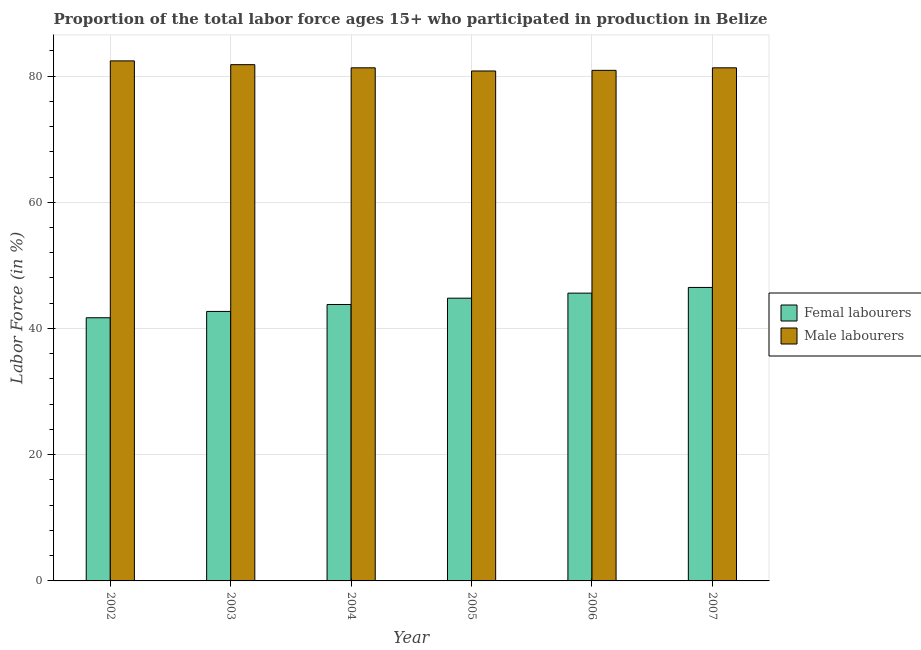How many different coloured bars are there?
Offer a very short reply. 2. How many groups of bars are there?
Provide a succinct answer. 6. Are the number of bars on each tick of the X-axis equal?
Ensure brevity in your answer.  Yes. What is the label of the 5th group of bars from the left?
Your answer should be very brief. 2006. In how many cases, is the number of bars for a given year not equal to the number of legend labels?
Offer a very short reply. 0. What is the percentage of male labour force in 2007?
Offer a very short reply. 81.3. Across all years, what is the maximum percentage of female labor force?
Your response must be concise. 46.5. Across all years, what is the minimum percentage of female labor force?
Your answer should be very brief. 41.7. In which year was the percentage of male labour force maximum?
Your answer should be very brief. 2002. In which year was the percentage of male labour force minimum?
Your answer should be compact. 2005. What is the total percentage of male labour force in the graph?
Provide a short and direct response. 488.5. What is the average percentage of male labour force per year?
Make the answer very short. 81.42. In the year 2004, what is the difference between the percentage of female labor force and percentage of male labour force?
Provide a short and direct response. 0. In how many years, is the percentage of female labor force greater than 16 %?
Your answer should be compact. 6. What is the ratio of the percentage of female labor force in 2003 to that in 2004?
Give a very brief answer. 0.97. Is the difference between the percentage of female labor force in 2002 and 2007 greater than the difference between the percentage of male labour force in 2002 and 2007?
Make the answer very short. No. What is the difference between the highest and the second highest percentage of male labour force?
Your answer should be very brief. 0.6. What is the difference between the highest and the lowest percentage of male labour force?
Offer a very short reply. 1.6. In how many years, is the percentage of male labour force greater than the average percentage of male labour force taken over all years?
Provide a short and direct response. 2. What does the 2nd bar from the left in 2006 represents?
Your answer should be very brief. Male labourers. What does the 2nd bar from the right in 2006 represents?
Keep it short and to the point. Femal labourers. What is the difference between two consecutive major ticks on the Y-axis?
Give a very brief answer. 20. Does the graph contain any zero values?
Provide a succinct answer. No. Does the graph contain grids?
Provide a succinct answer. Yes. Where does the legend appear in the graph?
Your response must be concise. Center right. How many legend labels are there?
Ensure brevity in your answer.  2. How are the legend labels stacked?
Offer a terse response. Vertical. What is the title of the graph?
Offer a terse response. Proportion of the total labor force ages 15+ who participated in production in Belize. What is the Labor Force (in %) in Femal labourers in 2002?
Keep it short and to the point. 41.7. What is the Labor Force (in %) in Male labourers in 2002?
Make the answer very short. 82.4. What is the Labor Force (in %) of Femal labourers in 2003?
Offer a terse response. 42.7. What is the Labor Force (in %) of Male labourers in 2003?
Make the answer very short. 81.8. What is the Labor Force (in %) in Femal labourers in 2004?
Offer a terse response. 43.8. What is the Labor Force (in %) in Male labourers in 2004?
Your answer should be very brief. 81.3. What is the Labor Force (in %) of Femal labourers in 2005?
Make the answer very short. 44.8. What is the Labor Force (in %) of Male labourers in 2005?
Your answer should be compact. 80.8. What is the Labor Force (in %) in Femal labourers in 2006?
Keep it short and to the point. 45.6. What is the Labor Force (in %) in Male labourers in 2006?
Provide a succinct answer. 80.9. What is the Labor Force (in %) of Femal labourers in 2007?
Keep it short and to the point. 46.5. What is the Labor Force (in %) in Male labourers in 2007?
Give a very brief answer. 81.3. Across all years, what is the maximum Labor Force (in %) of Femal labourers?
Your answer should be very brief. 46.5. Across all years, what is the maximum Labor Force (in %) of Male labourers?
Provide a succinct answer. 82.4. Across all years, what is the minimum Labor Force (in %) of Femal labourers?
Offer a terse response. 41.7. Across all years, what is the minimum Labor Force (in %) of Male labourers?
Ensure brevity in your answer.  80.8. What is the total Labor Force (in %) of Femal labourers in the graph?
Ensure brevity in your answer.  265.1. What is the total Labor Force (in %) in Male labourers in the graph?
Your answer should be very brief. 488.5. What is the difference between the Labor Force (in %) in Femal labourers in 2002 and that in 2004?
Ensure brevity in your answer.  -2.1. What is the difference between the Labor Force (in %) of Femal labourers in 2002 and that in 2005?
Your answer should be compact. -3.1. What is the difference between the Labor Force (in %) in Male labourers in 2002 and that in 2005?
Keep it short and to the point. 1.6. What is the difference between the Labor Force (in %) of Femal labourers in 2002 and that in 2006?
Your answer should be compact. -3.9. What is the difference between the Labor Force (in %) in Male labourers in 2002 and that in 2006?
Provide a short and direct response. 1.5. What is the difference between the Labor Force (in %) in Femal labourers in 2002 and that in 2007?
Give a very brief answer. -4.8. What is the difference between the Labor Force (in %) in Male labourers in 2003 and that in 2004?
Your answer should be very brief. 0.5. What is the difference between the Labor Force (in %) of Femal labourers in 2003 and that in 2005?
Your answer should be compact. -2.1. What is the difference between the Labor Force (in %) of Femal labourers in 2003 and that in 2006?
Your response must be concise. -2.9. What is the difference between the Labor Force (in %) in Male labourers in 2003 and that in 2006?
Give a very brief answer. 0.9. What is the difference between the Labor Force (in %) in Femal labourers in 2003 and that in 2007?
Ensure brevity in your answer.  -3.8. What is the difference between the Labor Force (in %) of Male labourers in 2003 and that in 2007?
Keep it short and to the point. 0.5. What is the difference between the Labor Force (in %) of Male labourers in 2004 and that in 2005?
Keep it short and to the point. 0.5. What is the difference between the Labor Force (in %) of Femal labourers in 2004 and that in 2007?
Your response must be concise. -2.7. What is the difference between the Labor Force (in %) of Femal labourers in 2005 and that in 2006?
Ensure brevity in your answer.  -0.8. What is the difference between the Labor Force (in %) of Femal labourers in 2005 and that in 2007?
Your response must be concise. -1.7. What is the difference between the Labor Force (in %) of Male labourers in 2005 and that in 2007?
Your answer should be very brief. -0.5. What is the difference between the Labor Force (in %) of Male labourers in 2006 and that in 2007?
Give a very brief answer. -0.4. What is the difference between the Labor Force (in %) in Femal labourers in 2002 and the Labor Force (in %) in Male labourers in 2003?
Provide a short and direct response. -40.1. What is the difference between the Labor Force (in %) of Femal labourers in 2002 and the Labor Force (in %) of Male labourers in 2004?
Your answer should be compact. -39.6. What is the difference between the Labor Force (in %) of Femal labourers in 2002 and the Labor Force (in %) of Male labourers in 2005?
Provide a short and direct response. -39.1. What is the difference between the Labor Force (in %) in Femal labourers in 2002 and the Labor Force (in %) in Male labourers in 2006?
Provide a succinct answer. -39.2. What is the difference between the Labor Force (in %) of Femal labourers in 2002 and the Labor Force (in %) of Male labourers in 2007?
Offer a terse response. -39.6. What is the difference between the Labor Force (in %) of Femal labourers in 2003 and the Labor Force (in %) of Male labourers in 2004?
Keep it short and to the point. -38.6. What is the difference between the Labor Force (in %) of Femal labourers in 2003 and the Labor Force (in %) of Male labourers in 2005?
Offer a terse response. -38.1. What is the difference between the Labor Force (in %) of Femal labourers in 2003 and the Labor Force (in %) of Male labourers in 2006?
Provide a short and direct response. -38.2. What is the difference between the Labor Force (in %) of Femal labourers in 2003 and the Labor Force (in %) of Male labourers in 2007?
Keep it short and to the point. -38.6. What is the difference between the Labor Force (in %) in Femal labourers in 2004 and the Labor Force (in %) in Male labourers in 2005?
Your answer should be compact. -37. What is the difference between the Labor Force (in %) of Femal labourers in 2004 and the Labor Force (in %) of Male labourers in 2006?
Your answer should be very brief. -37.1. What is the difference between the Labor Force (in %) in Femal labourers in 2004 and the Labor Force (in %) in Male labourers in 2007?
Offer a terse response. -37.5. What is the difference between the Labor Force (in %) of Femal labourers in 2005 and the Labor Force (in %) of Male labourers in 2006?
Make the answer very short. -36.1. What is the difference between the Labor Force (in %) in Femal labourers in 2005 and the Labor Force (in %) in Male labourers in 2007?
Make the answer very short. -36.5. What is the difference between the Labor Force (in %) of Femal labourers in 2006 and the Labor Force (in %) of Male labourers in 2007?
Your answer should be very brief. -35.7. What is the average Labor Force (in %) in Femal labourers per year?
Provide a short and direct response. 44.18. What is the average Labor Force (in %) in Male labourers per year?
Make the answer very short. 81.42. In the year 2002, what is the difference between the Labor Force (in %) of Femal labourers and Labor Force (in %) of Male labourers?
Make the answer very short. -40.7. In the year 2003, what is the difference between the Labor Force (in %) in Femal labourers and Labor Force (in %) in Male labourers?
Make the answer very short. -39.1. In the year 2004, what is the difference between the Labor Force (in %) in Femal labourers and Labor Force (in %) in Male labourers?
Your response must be concise. -37.5. In the year 2005, what is the difference between the Labor Force (in %) of Femal labourers and Labor Force (in %) of Male labourers?
Give a very brief answer. -36. In the year 2006, what is the difference between the Labor Force (in %) in Femal labourers and Labor Force (in %) in Male labourers?
Ensure brevity in your answer.  -35.3. In the year 2007, what is the difference between the Labor Force (in %) in Femal labourers and Labor Force (in %) in Male labourers?
Make the answer very short. -34.8. What is the ratio of the Labor Force (in %) in Femal labourers in 2002 to that in 2003?
Keep it short and to the point. 0.98. What is the ratio of the Labor Force (in %) in Male labourers in 2002 to that in 2003?
Your answer should be compact. 1.01. What is the ratio of the Labor Force (in %) of Femal labourers in 2002 to that in 2004?
Provide a succinct answer. 0.95. What is the ratio of the Labor Force (in %) in Male labourers in 2002 to that in 2004?
Keep it short and to the point. 1.01. What is the ratio of the Labor Force (in %) of Femal labourers in 2002 to that in 2005?
Make the answer very short. 0.93. What is the ratio of the Labor Force (in %) in Male labourers in 2002 to that in 2005?
Offer a terse response. 1.02. What is the ratio of the Labor Force (in %) of Femal labourers in 2002 to that in 2006?
Ensure brevity in your answer.  0.91. What is the ratio of the Labor Force (in %) in Male labourers in 2002 to that in 2006?
Your response must be concise. 1.02. What is the ratio of the Labor Force (in %) in Femal labourers in 2002 to that in 2007?
Offer a terse response. 0.9. What is the ratio of the Labor Force (in %) in Male labourers in 2002 to that in 2007?
Make the answer very short. 1.01. What is the ratio of the Labor Force (in %) in Femal labourers in 2003 to that in 2004?
Give a very brief answer. 0.97. What is the ratio of the Labor Force (in %) in Femal labourers in 2003 to that in 2005?
Your answer should be very brief. 0.95. What is the ratio of the Labor Force (in %) of Male labourers in 2003 to that in 2005?
Make the answer very short. 1.01. What is the ratio of the Labor Force (in %) in Femal labourers in 2003 to that in 2006?
Offer a very short reply. 0.94. What is the ratio of the Labor Force (in %) of Male labourers in 2003 to that in 2006?
Offer a very short reply. 1.01. What is the ratio of the Labor Force (in %) of Femal labourers in 2003 to that in 2007?
Provide a succinct answer. 0.92. What is the ratio of the Labor Force (in %) in Male labourers in 2003 to that in 2007?
Give a very brief answer. 1.01. What is the ratio of the Labor Force (in %) in Femal labourers in 2004 to that in 2005?
Your response must be concise. 0.98. What is the ratio of the Labor Force (in %) of Male labourers in 2004 to that in 2005?
Give a very brief answer. 1.01. What is the ratio of the Labor Force (in %) of Femal labourers in 2004 to that in 2006?
Offer a terse response. 0.96. What is the ratio of the Labor Force (in %) of Male labourers in 2004 to that in 2006?
Keep it short and to the point. 1. What is the ratio of the Labor Force (in %) of Femal labourers in 2004 to that in 2007?
Ensure brevity in your answer.  0.94. What is the ratio of the Labor Force (in %) of Femal labourers in 2005 to that in 2006?
Provide a succinct answer. 0.98. What is the ratio of the Labor Force (in %) of Femal labourers in 2005 to that in 2007?
Provide a succinct answer. 0.96. What is the ratio of the Labor Force (in %) in Femal labourers in 2006 to that in 2007?
Offer a very short reply. 0.98. 